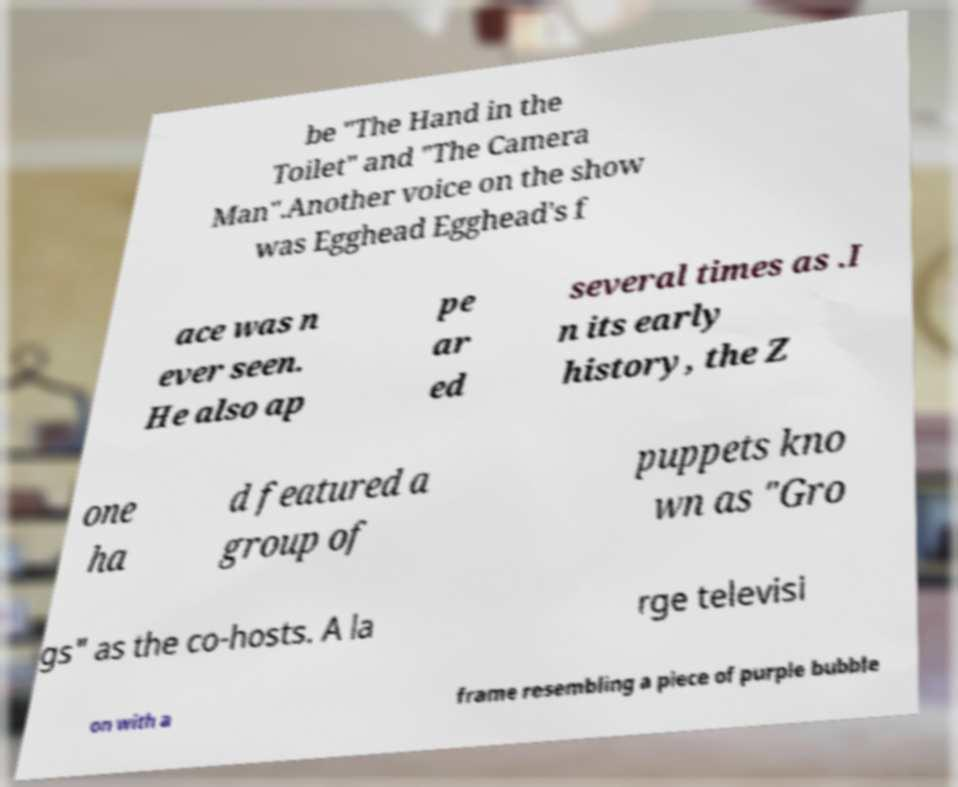What messages or text are displayed in this image? I need them in a readable, typed format. be "The Hand in the Toilet" and "The Camera Man".Another voice on the show was Egghead Egghead's f ace was n ever seen. He also ap pe ar ed several times as .I n its early history, the Z one ha d featured a group of puppets kno wn as "Gro gs" as the co-hosts. A la rge televisi on with a frame resembling a piece of purple bubble 